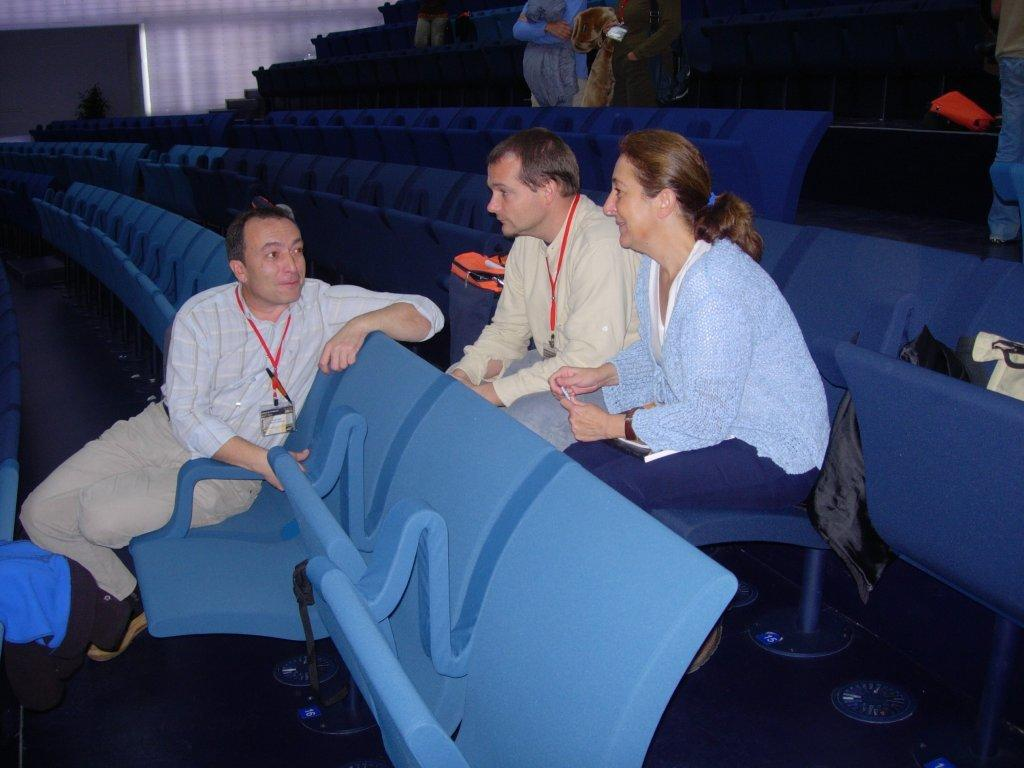What are the people in the image doing? There are people sitting on chairs and standing in the image. What is on the chairs in the image? There are objects on the chairs in the image. How would you describe the color scheme of the background in the image? The background of the image has a white and black color scheme. How do the people in the image express their love for each other? There is no indication of love or affection between the people in the image. 